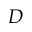Convert formula to latex. <formula><loc_0><loc_0><loc_500><loc_500>D</formula> 